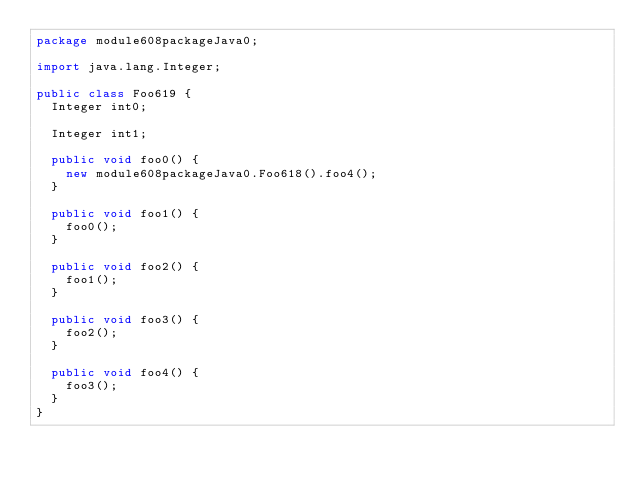<code> <loc_0><loc_0><loc_500><loc_500><_Java_>package module608packageJava0;

import java.lang.Integer;

public class Foo619 {
  Integer int0;

  Integer int1;

  public void foo0() {
    new module608packageJava0.Foo618().foo4();
  }

  public void foo1() {
    foo0();
  }

  public void foo2() {
    foo1();
  }

  public void foo3() {
    foo2();
  }

  public void foo4() {
    foo3();
  }
}
</code> 